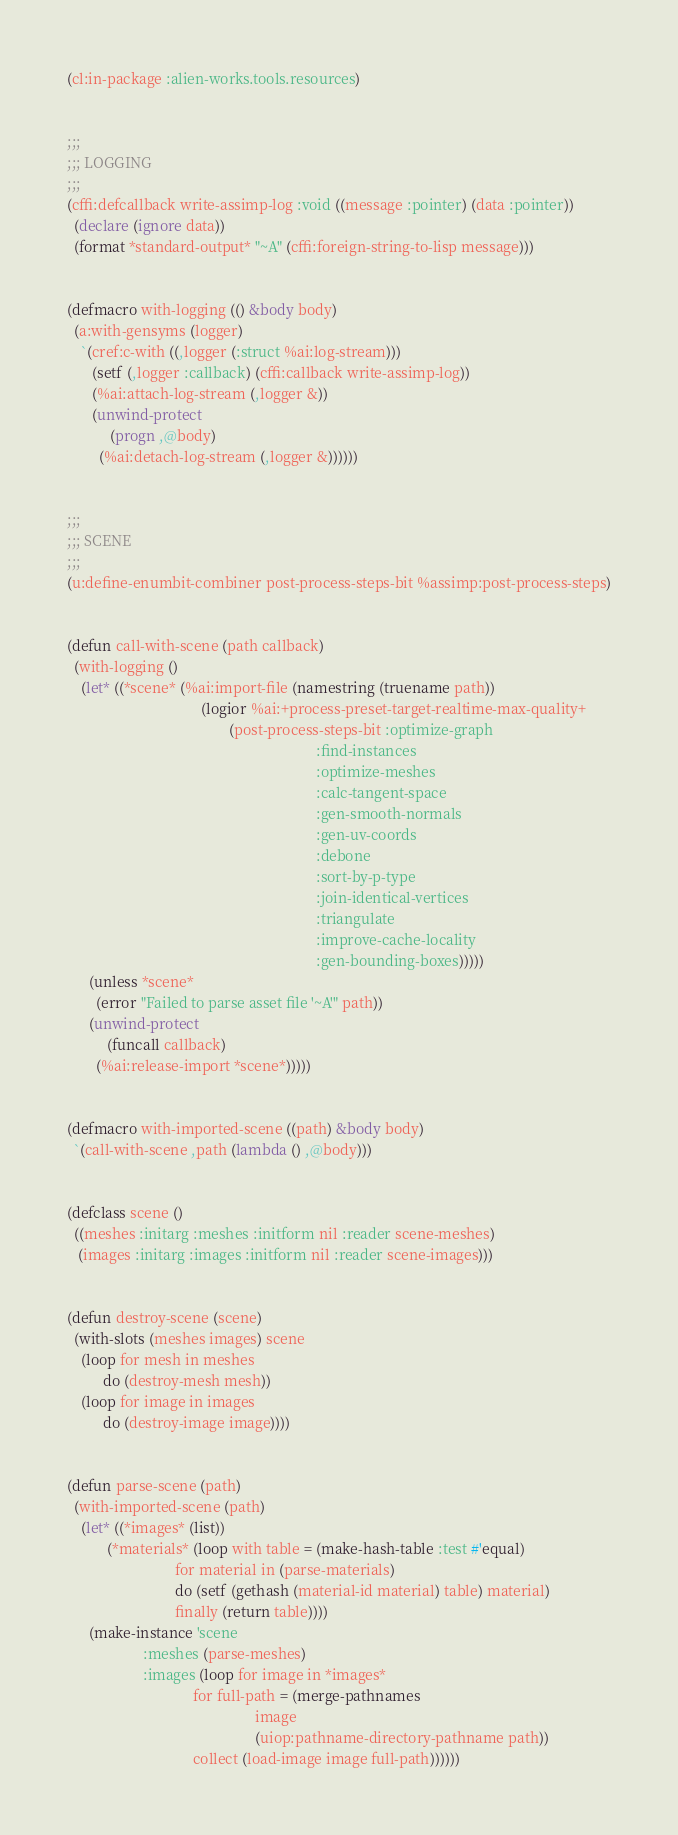Convert code to text. <code><loc_0><loc_0><loc_500><loc_500><_Lisp_>(cl:in-package :alien-works.tools.resources)


;;;
;;; LOGGING
;;;
(cffi:defcallback write-assimp-log :void ((message :pointer) (data :pointer))
  (declare (ignore data))
  (format *standard-output* "~A" (cffi:foreign-string-to-lisp message)))


(defmacro with-logging (() &body body)
  (a:with-gensyms (logger)
    `(cref:c-with ((,logger (:struct %ai:log-stream)))
       (setf (,logger :callback) (cffi:callback write-assimp-log))
       (%ai:attach-log-stream (,logger &))
       (unwind-protect
            (progn ,@body)
         (%ai:detach-log-stream (,logger &))))))


;;;
;;; SCENE
;;;
(u:define-enumbit-combiner post-process-steps-bit %assimp:post-process-steps)


(defun call-with-scene (path callback)
  (with-logging ()
    (let* ((*scene* (%ai:import-file (namestring (truename path))
                                     (logior %ai:+process-preset-target-realtime-max-quality+
                                             (post-process-steps-bit :optimize-graph
                                                                     :find-instances
                                                                     :optimize-meshes
                                                                     :calc-tangent-space
                                                                     :gen-smooth-normals
                                                                     :gen-uv-coords
                                                                     :debone
                                                                     :sort-by-p-type
                                                                     :join-identical-vertices
                                                                     :triangulate
                                                                     :improve-cache-locality
                                                                     :gen-bounding-boxes)))))
      (unless *scene*
        (error "Failed to parse asset file '~A'" path))
      (unwind-protect
           (funcall callback)
        (%ai:release-import *scene*)))))


(defmacro with-imported-scene ((path) &body body)
  `(call-with-scene ,path (lambda () ,@body)))


(defclass scene ()
  ((meshes :initarg :meshes :initform nil :reader scene-meshes)
   (images :initarg :images :initform nil :reader scene-images)))


(defun destroy-scene (scene)
  (with-slots (meshes images) scene
    (loop for mesh in meshes
          do (destroy-mesh mesh))
    (loop for image in images
          do (destroy-image image))))


(defun parse-scene (path)
  (with-imported-scene (path)
    (let* ((*images* (list))
           (*materials* (loop with table = (make-hash-table :test #'equal)
                              for material in (parse-materials)
                              do (setf (gethash (material-id material) table) material)
                              finally (return table))))
      (make-instance 'scene
                     :meshes (parse-meshes)
                     :images (loop for image in *images*
                                   for full-path = (merge-pathnames
                                                    image
                                                    (uiop:pathname-directory-pathname path))
                                   collect (load-image image full-path))))))
</code> 